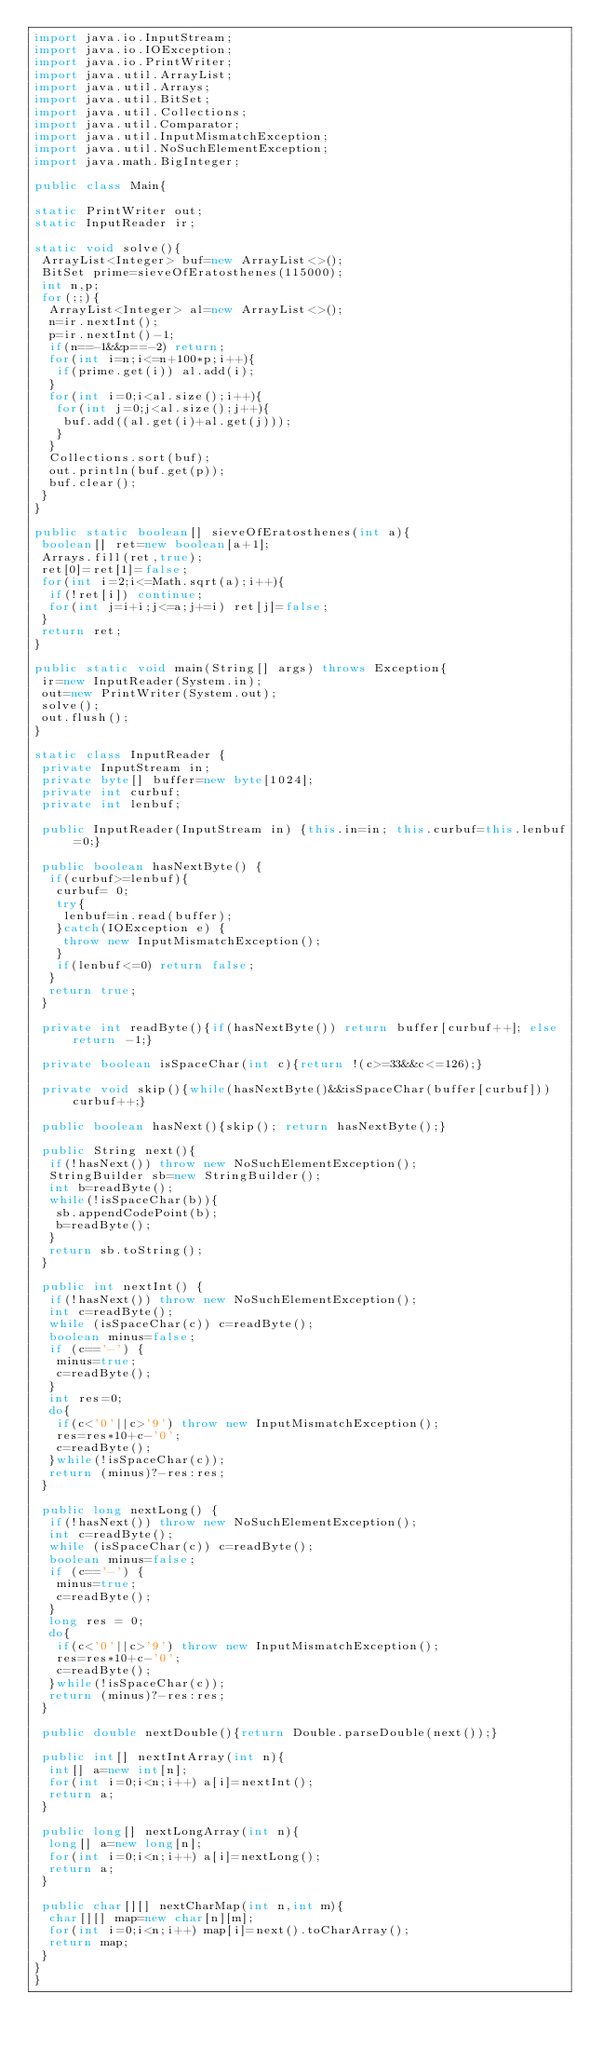Convert code to text. <code><loc_0><loc_0><loc_500><loc_500><_Java_>import java.io.InputStream;
import java.io.IOException;
import java.io.PrintWriter;
import java.util.ArrayList;
import java.util.Arrays;
import java.util.BitSet;
import java.util.Collections;
import java.util.Comparator;
import java.util.InputMismatchException;
import java.util.NoSuchElementException;
import java.math.BigInteger;

public class Main{

static PrintWriter out;
static InputReader ir;

static void solve(){
 ArrayList<Integer> buf=new ArrayList<>();
 BitSet prime=sieveOfEratosthenes(115000);
 int n,p;
 for(;;){
  ArrayList<Integer> al=new ArrayList<>();
  n=ir.nextInt();
  p=ir.nextInt()-1;
  if(n==-1&&p==-2) return;
  for(int i=n;i<=n+100*p;i++){
   if(prime.get(i)) al.add(i);
  }
  for(int i=0;i<al.size();i++){
   for(int j=0;j<al.size();j++){
    buf.add((al.get(i)+al.get(j)));
   }
  }
  Collections.sort(buf);
  out.println(buf.get(p));
  buf.clear();
 }
}

public static boolean[] sieveOfEratosthenes(int a){
 boolean[] ret=new boolean[a+1];
 Arrays.fill(ret,true);
 ret[0]=ret[1]=false;
 for(int i=2;i<=Math.sqrt(a);i++){
  if(!ret[i]) continue;
  for(int j=i+i;j<=a;j+=i) ret[j]=false;
 }
 return ret;
}

public static void main(String[] args) throws Exception{
 ir=new InputReader(System.in);
 out=new PrintWriter(System.out);
 solve();
 out.flush();
}

static class InputReader {
 private InputStream in;
 private byte[] buffer=new byte[1024];
 private int curbuf;
 private int lenbuf;

 public InputReader(InputStream in) {this.in=in; this.curbuf=this.lenbuf=0;}
 
 public boolean hasNextByte() {
  if(curbuf>=lenbuf){
   curbuf= 0;
   try{
    lenbuf=in.read(buffer);
   }catch(IOException e) {
    throw new InputMismatchException();
   }
   if(lenbuf<=0) return false;
  }
  return true;
 }

 private int readByte(){if(hasNextByte()) return buffer[curbuf++]; else return -1;}
 
 private boolean isSpaceChar(int c){return !(c>=33&&c<=126);}
 
 private void skip(){while(hasNextByte()&&isSpaceChar(buffer[curbuf])) curbuf++;}
 
 public boolean hasNext(){skip(); return hasNextByte();}
 
 public String next(){
  if(!hasNext()) throw new NoSuchElementException();
  StringBuilder sb=new StringBuilder();
  int b=readByte();
  while(!isSpaceChar(b)){
   sb.appendCodePoint(b);
   b=readByte();
  }
  return sb.toString();
 }
 
 public int nextInt() {
  if(!hasNext()) throw new NoSuchElementException();
  int c=readByte();
  while (isSpaceChar(c)) c=readByte();
  boolean minus=false;
  if (c=='-') {
   minus=true;
   c=readByte();
  }
  int res=0;
  do{
   if(c<'0'||c>'9') throw new InputMismatchException();
   res=res*10+c-'0';
   c=readByte();
  }while(!isSpaceChar(c));
  return (minus)?-res:res;
 }
 
 public long nextLong() {
  if(!hasNext()) throw new NoSuchElementException();
  int c=readByte();
  while (isSpaceChar(c)) c=readByte();
  boolean minus=false;
  if (c=='-') {
   minus=true;
   c=readByte();
  }
  long res = 0;
  do{
   if(c<'0'||c>'9') throw new InputMismatchException();
   res=res*10+c-'0';
   c=readByte();
  }while(!isSpaceChar(c));
  return (minus)?-res:res;
 }

 public double nextDouble(){return Double.parseDouble(next());}

 public int[] nextIntArray(int n){
  int[] a=new int[n];
  for(int i=0;i<n;i++) a[i]=nextInt();
  return a;
 }

 public long[] nextLongArray(int n){
  long[] a=new long[n];
  for(int i=0;i<n;i++) a[i]=nextLong();
  return a;
 }

 public char[][] nextCharMap(int n,int m){
  char[][] map=new char[n][m];
  for(int i=0;i<n;i++) map[i]=next().toCharArray();
  return map;
 }
}
}</code> 